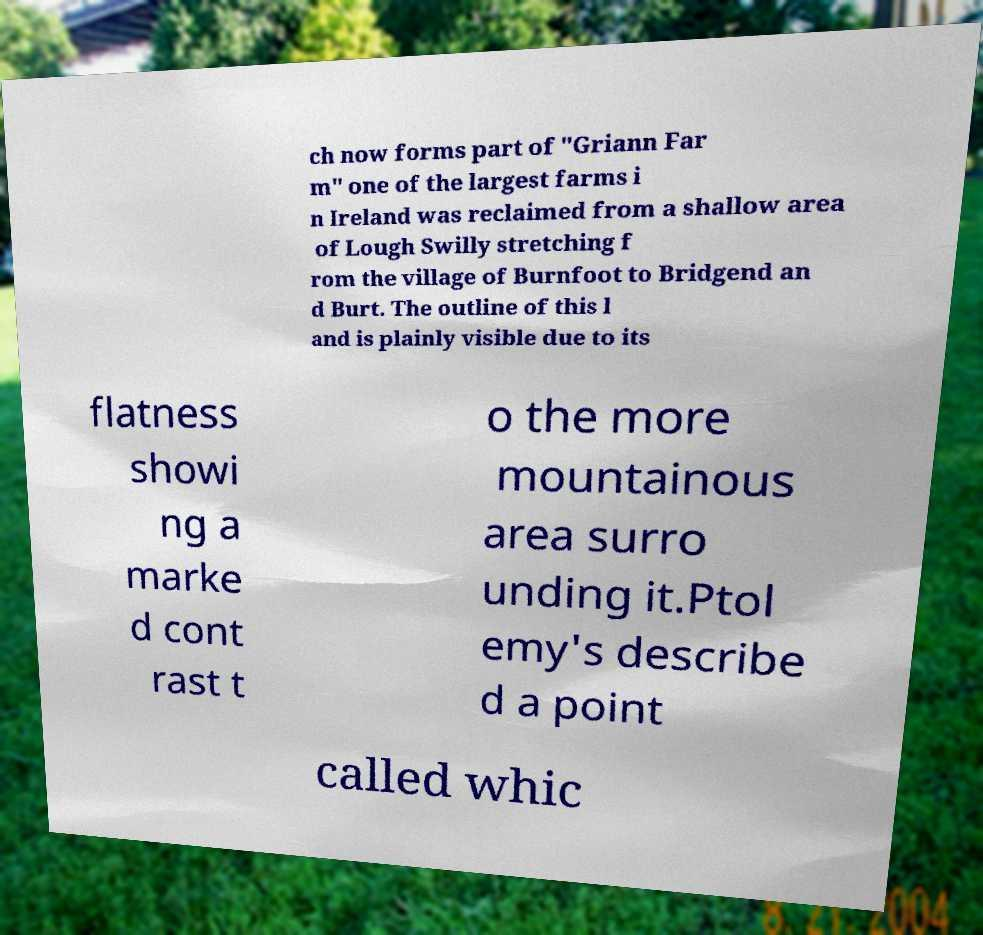For documentation purposes, I need the text within this image transcribed. Could you provide that? ch now forms part of "Griann Far m" one of the largest farms i n Ireland was reclaimed from a shallow area of Lough Swilly stretching f rom the village of Burnfoot to Bridgend an d Burt. The outline of this l and is plainly visible due to its flatness showi ng a marke d cont rast t o the more mountainous area surro unding it.Ptol emy's describe d a point called whic 